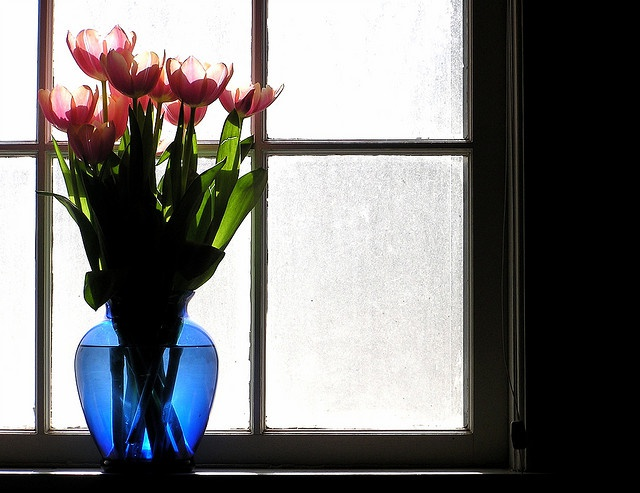Describe the objects in this image and their specific colors. I can see a vase in white, black, lightblue, and blue tones in this image. 